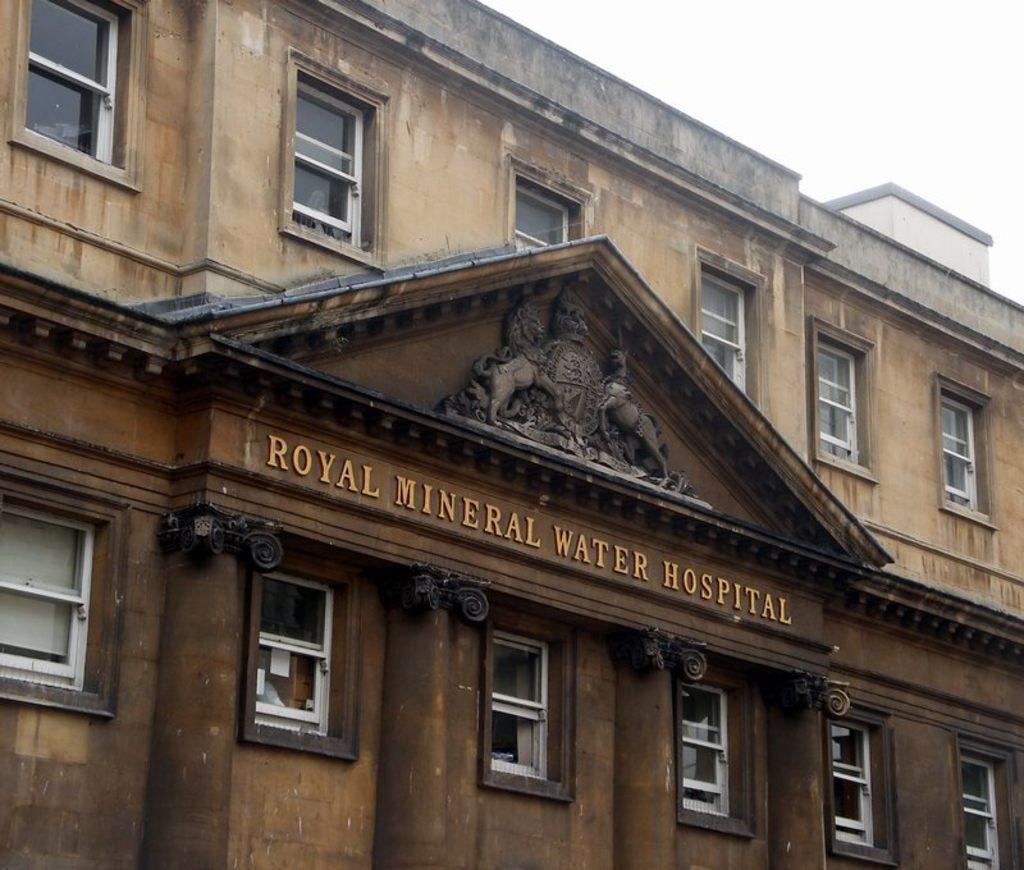Please provide a concise description of this image. In this image there is a building on that building there is a text. 